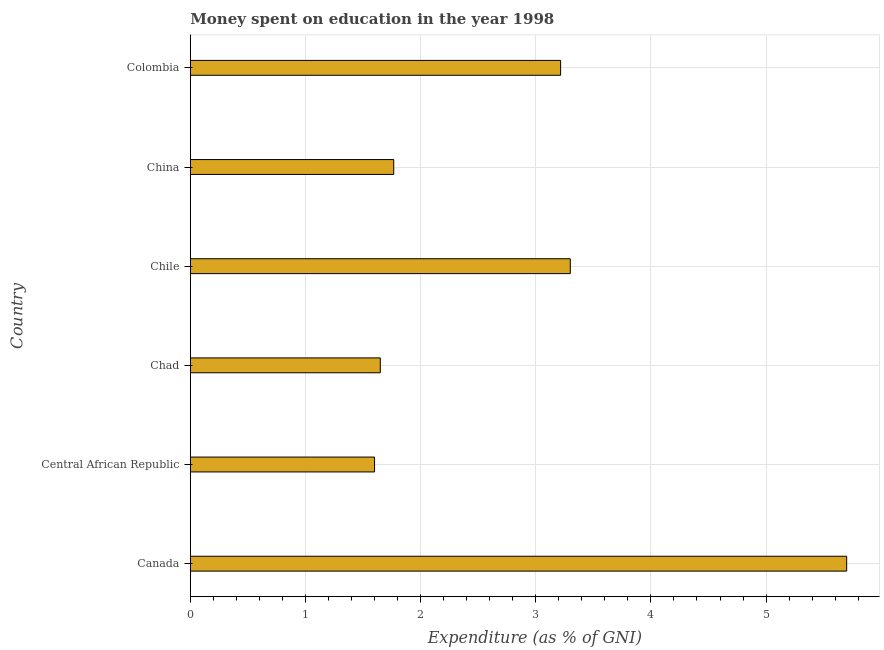Does the graph contain grids?
Give a very brief answer. Yes. What is the title of the graph?
Your answer should be very brief. Money spent on education in the year 1998. What is the label or title of the X-axis?
Provide a succinct answer. Expenditure (as % of GNI). What is the label or title of the Y-axis?
Your response must be concise. Country. What is the expenditure on education in Colombia?
Keep it short and to the point. 3.22. Across all countries, what is the maximum expenditure on education?
Your response must be concise. 5.7. Across all countries, what is the minimum expenditure on education?
Ensure brevity in your answer.  1.6. In which country was the expenditure on education maximum?
Your response must be concise. Canada. In which country was the expenditure on education minimum?
Your answer should be very brief. Central African Republic. What is the sum of the expenditure on education?
Provide a short and direct response. 17.23. What is the difference between the expenditure on education in Chile and Colombia?
Offer a very short reply. 0.08. What is the average expenditure on education per country?
Your answer should be very brief. 2.87. What is the median expenditure on education?
Your answer should be very brief. 2.49. In how many countries, is the expenditure on education greater than 2.8 %?
Offer a terse response. 3. What is the ratio of the expenditure on education in Canada to that in China?
Provide a succinct answer. 3.23. Is the expenditure on education in Chad less than that in China?
Your answer should be compact. Yes. Is the difference between the expenditure on education in Central African Republic and Chile greater than the difference between any two countries?
Give a very brief answer. No. Is the sum of the expenditure on education in Central African Republic and China greater than the maximum expenditure on education across all countries?
Your answer should be compact. No. What is the difference between the highest and the lowest expenditure on education?
Keep it short and to the point. 4.1. How many bars are there?
Keep it short and to the point. 6. Are all the bars in the graph horizontal?
Your answer should be compact. Yes. What is the difference between two consecutive major ticks on the X-axis?
Provide a succinct answer. 1. Are the values on the major ticks of X-axis written in scientific E-notation?
Make the answer very short. No. What is the Expenditure (as % of GNI) in Canada?
Give a very brief answer. 5.7. What is the Expenditure (as % of GNI) in Central African Republic?
Your response must be concise. 1.6. What is the Expenditure (as % of GNI) of Chad?
Make the answer very short. 1.65. What is the Expenditure (as % of GNI) in Chile?
Offer a terse response. 3.3. What is the Expenditure (as % of GNI) of China?
Give a very brief answer. 1.77. What is the Expenditure (as % of GNI) of Colombia?
Your response must be concise. 3.22. What is the difference between the Expenditure (as % of GNI) in Canada and Chad?
Your response must be concise. 4.05. What is the difference between the Expenditure (as % of GNI) in Canada and China?
Offer a very short reply. 3.93. What is the difference between the Expenditure (as % of GNI) in Canada and Colombia?
Keep it short and to the point. 2.48. What is the difference between the Expenditure (as % of GNI) in Central African Republic and China?
Give a very brief answer. -0.17. What is the difference between the Expenditure (as % of GNI) in Central African Republic and Colombia?
Ensure brevity in your answer.  -1.62. What is the difference between the Expenditure (as % of GNI) in Chad and Chile?
Keep it short and to the point. -1.65. What is the difference between the Expenditure (as % of GNI) in Chad and China?
Provide a succinct answer. -0.12. What is the difference between the Expenditure (as % of GNI) in Chad and Colombia?
Keep it short and to the point. -1.57. What is the difference between the Expenditure (as % of GNI) in Chile and China?
Offer a terse response. 1.53. What is the difference between the Expenditure (as % of GNI) in Chile and Colombia?
Keep it short and to the point. 0.08. What is the difference between the Expenditure (as % of GNI) in China and Colombia?
Make the answer very short. -1.45. What is the ratio of the Expenditure (as % of GNI) in Canada to that in Central African Republic?
Keep it short and to the point. 3.56. What is the ratio of the Expenditure (as % of GNI) in Canada to that in Chad?
Your response must be concise. 3.46. What is the ratio of the Expenditure (as % of GNI) in Canada to that in Chile?
Offer a very short reply. 1.73. What is the ratio of the Expenditure (as % of GNI) in Canada to that in China?
Provide a short and direct response. 3.23. What is the ratio of the Expenditure (as % of GNI) in Canada to that in Colombia?
Your answer should be compact. 1.77. What is the ratio of the Expenditure (as % of GNI) in Central African Republic to that in Chile?
Keep it short and to the point. 0.48. What is the ratio of the Expenditure (as % of GNI) in Central African Republic to that in China?
Provide a short and direct response. 0.91. What is the ratio of the Expenditure (as % of GNI) in Central African Republic to that in Colombia?
Offer a terse response. 0.5. What is the ratio of the Expenditure (as % of GNI) in Chad to that in China?
Make the answer very short. 0.93. What is the ratio of the Expenditure (as % of GNI) in Chad to that in Colombia?
Your answer should be very brief. 0.51. What is the ratio of the Expenditure (as % of GNI) in Chile to that in China?
Provide a succinct answer. 1.87. What is the ratio of the Expenditure (as % of GNI) in China to that in Colombia?
Your response must be concise. 0.55. 